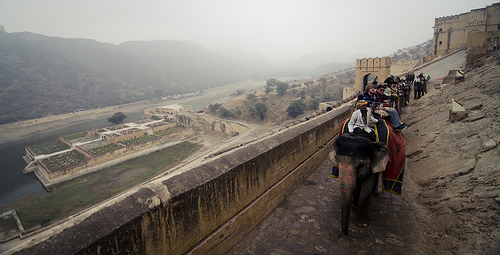Can you tell more about the history or significance of the location displayed? This location appears to be a historic fort in India, likely used for defensive purposes given its elevated structure. The path is likely an ancient route for patrols or transport within the fort premises, now repurposed as a path for tourist elephant rides which showcase the spectacular views and rich history of the architecture. 